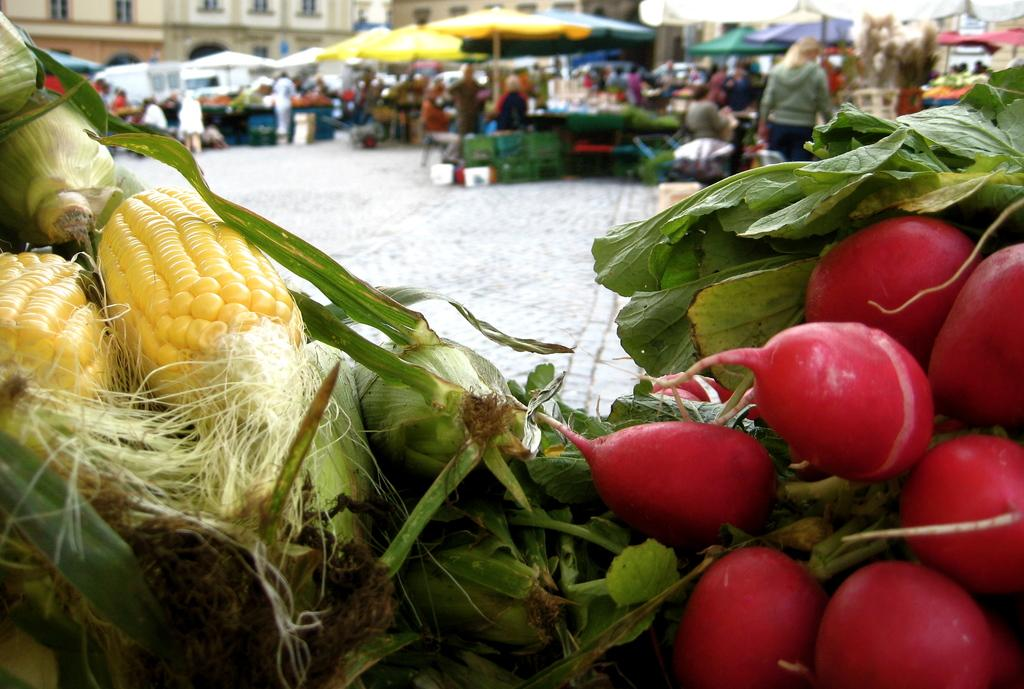What types of vegetables can be seen in the image? There are two types of vegetables in the image. What is happening in the background of the image? There are people standing under tents in the background of the image. What structures are visible in the image? There are buildings visible in the image. What can be seen beneath the people and buildings in the image? The ground is visible in the image. Reasoning: Let'g: Let's think step by step in order to produce the conversation. We start by identifying the main subject in the image, which is the vegetables. Then, we expand the conversation to include other elements in the image, such as the people, tents, buildings, and ground. Each question is designed to elicit a specific detail about the image that is known from the provided facts. Absurd Question/Answer: Where is the hydrant located in the image? There is no hydrant present in the image. What type of development is taking place in the image? The image does not depict any development; it shows vegetables, people, tents, buildings, and the ground. What type of hole can be seen in the image? There is no hole present in the image. What type of creature is interacting with the vegetables in the image? There is no creature interacting with the vegetables in the image; it only shows the vegetables, people, tents, buildings, and the ground. 